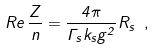<formula> <loc_0><loc_0><loc_500><loc_500>R e \, \frac { Z } { n } = \frac { 4 \pi } { \Gamma _ { s } k _ { s } g ^ { 2 } } R _ { s } \ ,</formula> 